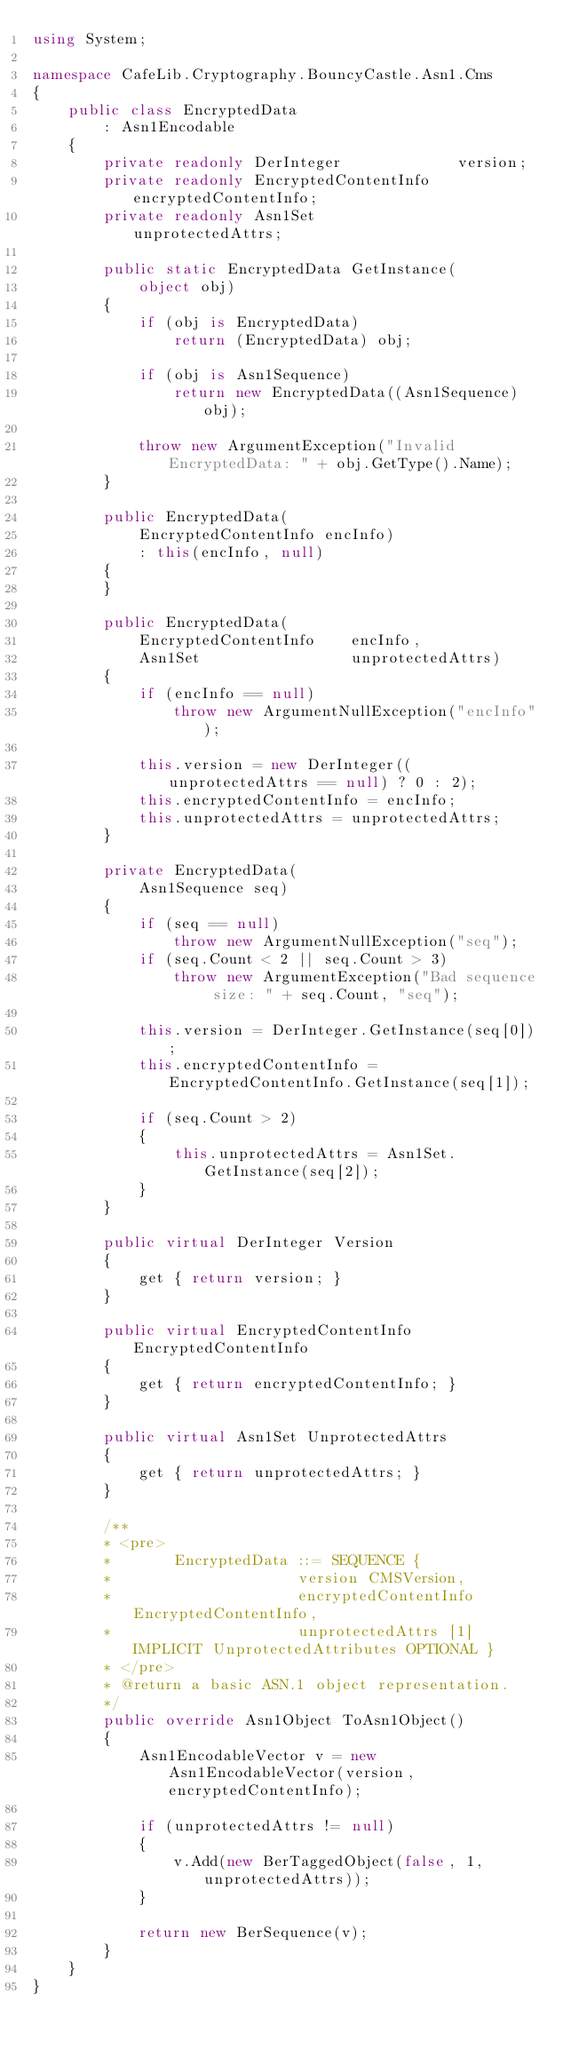Convert code to text. <code><loc_0><loc_0><loc_500><loc_500><_C#_>using System;

namespace CafeLib.Cryptography.BouncyCastle.Asn1.Cms
{
	public class EncryptedData
		: Asn1Encodable
	{
		private readonly DerInteger				version;
		private readonly EncryptedContentInfo	encryptedContentInfo;
		private readonly Asn1Set				unprotectedAttrs;

		public static EncryptedData GetInstance(
			object obj)
		{
			if (obj is EncryptedData)
				return (EncryptedData) obj;

			if (obj is Asn1Sequence)
				return new EncryptedData((Asn1Sequence) obj);

			throw new ArgumentException("Invalid EncryptedData: " + obj.GetType().Name);
		}

		public EncryptedData(
			EncryptedContentInfo encInfo)
			: this(encInfo, null)
		{
		}

		public EncryptedData(
			EncryptedContentInfo	encInfo,
			Asn1Set					unprotectedAttrs)
		{
			if (encInfo == null)
				throw new ArgumentNullException("encInfo");

			this.version = new DerInteger((unprotectedAttrs == null) ? 0 : 2);
			this.encryptedContentInfo = encInfo;
			this.unprotectedAttrs = unprotectedAttrs;
		}

		private EncryptedData(
			Asn1Sequence seq)
		{
			if (seq == null)
				throw new ArgumentNullException("seq");
			if (seq.Count < 2 || seq.Count > 3)
				throw new ArgumentException("Bad sequence size: " + seq.Count, "seq");

			this.version = DerInteger.GetInstance(seq[0]);
			this.encryptedContentInfo = EncryptedContentInfo.GetInstance(seq[1]);

			if (seq.Count > 2)
			{
				this.unprotectedAttrs = Asn1Set.GetInstance(seq[2]);
			}
		}

		public virtual DerInteger Version
		{
			get { return version; }
		}

		public virtual EncryptedContentInfo EncryptedContentInfo
		{
			get { return encryptedContentInfo; }
		}

		public virtual Asn1Set UnprotectedAttrs
		{
			get { return unprotectedAttrs; }
		}

		/**
		* <pre>
		*       EncryptedData ::= SEQUENCE {
		*                     version CMSVersion,
		*                     encryptedContentInfo EncryptedContentInfo,
		*                     unprotectedAttrs [1] IMPLICIT UnprotectedAttributes OPTIONAL }
		* </pre>
		* @return a basic ASN.1 object representation.
		*/
		public override Asn1Object ToAsn1Object()
		{
			Asn1EncodableVector v = new Asn1EncodableVector(version, encryptedContentInfo);

			if (unprotectedAttrs != null)
			{
				v.Add(new BerTaggedObject(false, 1, unprotectedAttrs));
			}

			return new BerSequence(v);
		}
	}
}
</code> 